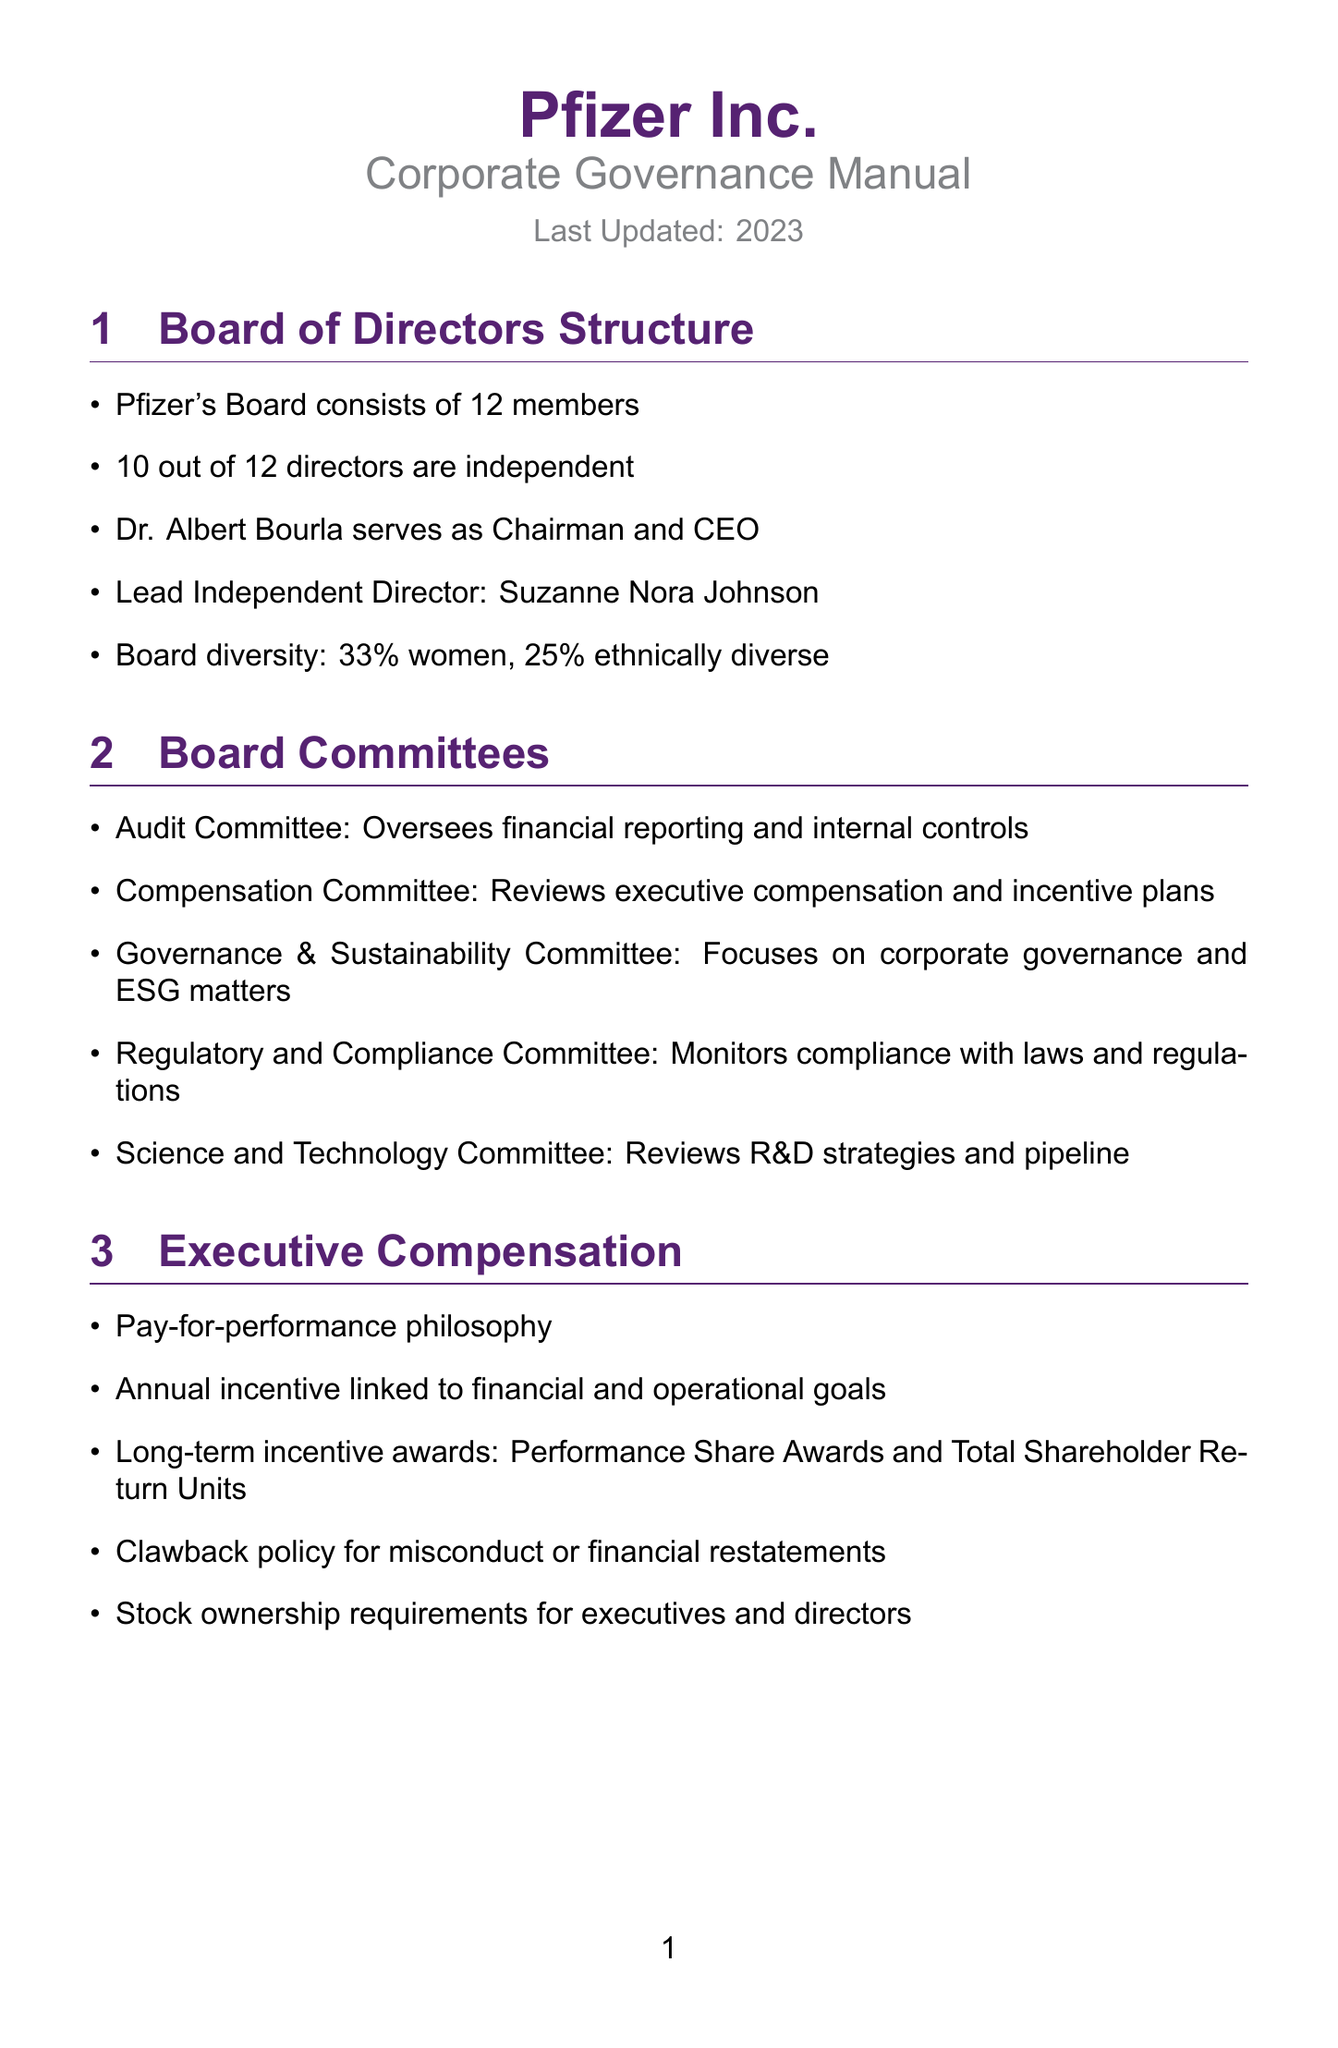what is the total number of board members? The document states that Pfizer's Board consists of 12 members.
Answer: 12 how many directors are independent? The document indicates that 10 out of 12 directors are independent.
Answer: 10 who is the Lead Independent Director? The document identifies Suzanne Nora Johnson as the Lead Independent Director.
Answer: Suzanne Nora Johnson what is the diversity percentage of women on the board? The document mentions that the Board diversity includes 33% women.
Answer: 33% which committee oversees financial reporting? The document specifies that the Audit Committee oversees financial reporting and internal controls.
Answer: Audit Committee what is the annual incentive linked to? The document states that the annual incentive is linked to financial and operational goals.
Answer: financial and operational goals what is the policy for executive compensation? The document outlines a pay-for-performance philosophy for executive compensation.
Answer: pay-for-performance philosophy how often are directors elected? The document states that there is an annual election of all directors.
Answer: annual when is the Annual Shareholder Meeting typically held? The document indicates that the Annual Shareholder Meeting is typically held in April.
Answer: April 